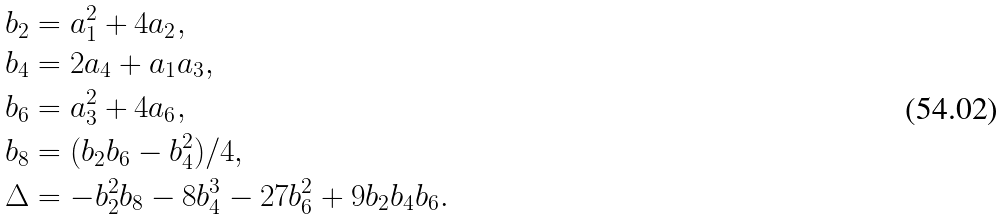Convert formula to latex. <formula><loc_0><loc_0><loc_500><loc_500>b _ { 2 } & = a _ { 1 } ^ { 2 } + 4 a _ { 2 } , \\ b _ { 4 } & = 2 a _ { 4 } + a _ { 1 } a _ { 3 } , \\ b _ { 6 } & = a _ { 3 } ^ { 2 } + 4 a _ { 6 } , \\ b _ { 8 } & = ( b _ { 2 } b _ { 6 } - b _ { 4 } ^ { 2 } ) / 4 , \\ \Delta & = - b _ { 2 } ^ { 2 } b _ { 8 } - 8 b _ { 4 } ^ { 3 } - 2 7 b _ { 6 } ^ { 2 } + 9 b _ { 2 } b _ { 4 } b _ { 6 } .</formula> 